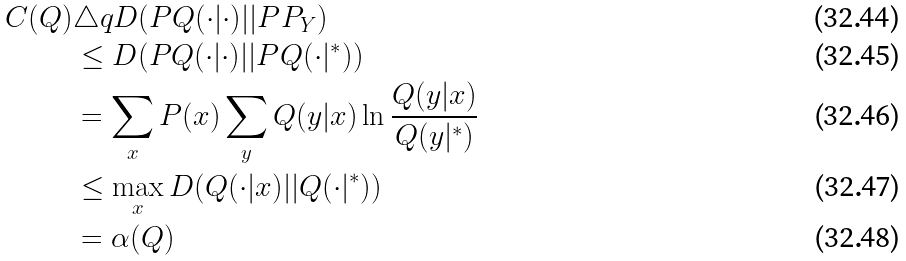<formula> <loc_0><loc_0><loc_500><loc_500>C ( Q ) & \triangle q D ( P Q ( \cdot | \cdot ) | | P P _ { Y } ) \\ & \leq D ( P Q ( \cdot | \cdot ) | | P Q ( \cdot | ^ { * } ) ) \\ & = \sum _ { x } P ( x ) \sum _ { y } Q ( y | x ) \ln \frac { Q ( y | x ) } { Q ( y | ^ { * } ) } \\ & \leq \max _ { x } D ( Q ( \cdot | x ) | | Q ( \cdot | ^ { * } ) ) \\ & = \alpha ( Q )</formula> 